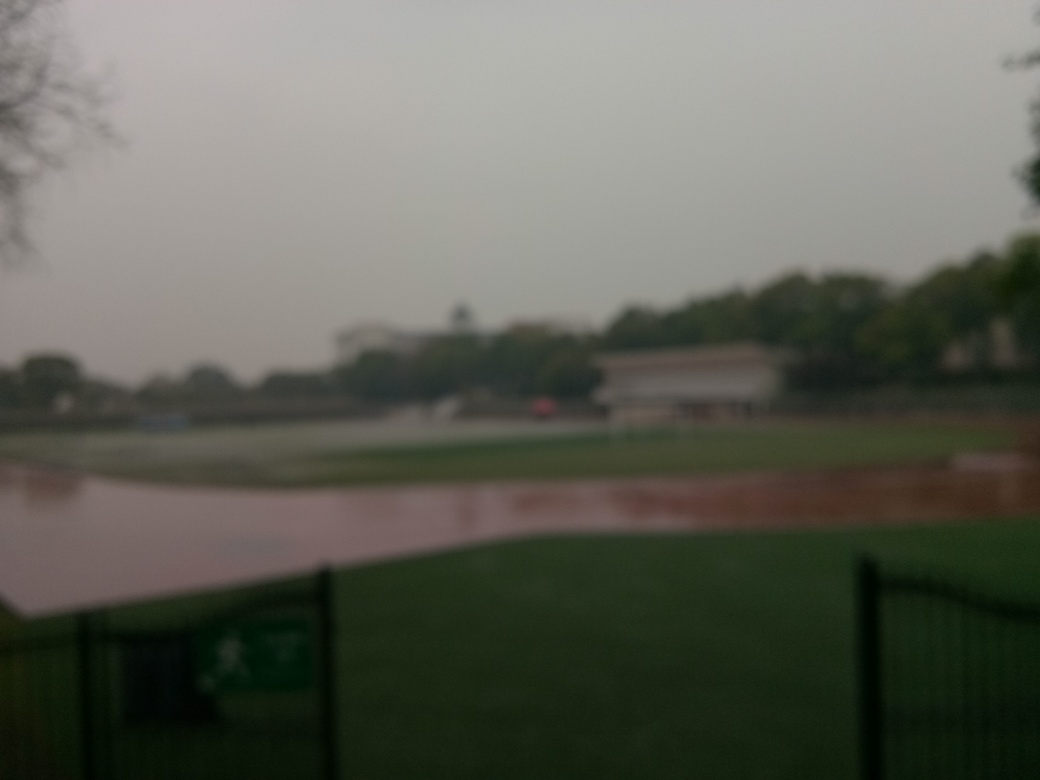Why is the quality of this image considered relatively poor? The quality of the image is considered poor primarily because of serious focusing issues and low overall sharpness, which makes it difficult to discern fine details or define clear edges within the scene. Furthermore, these issues could indicate the use of a low-quality camera or a camera mishandling issue such as movement during the shot or an incorrect focus setting. The lack of clarity substantially diminishes the impact of the image, rendering it less effective for visual purposes. 